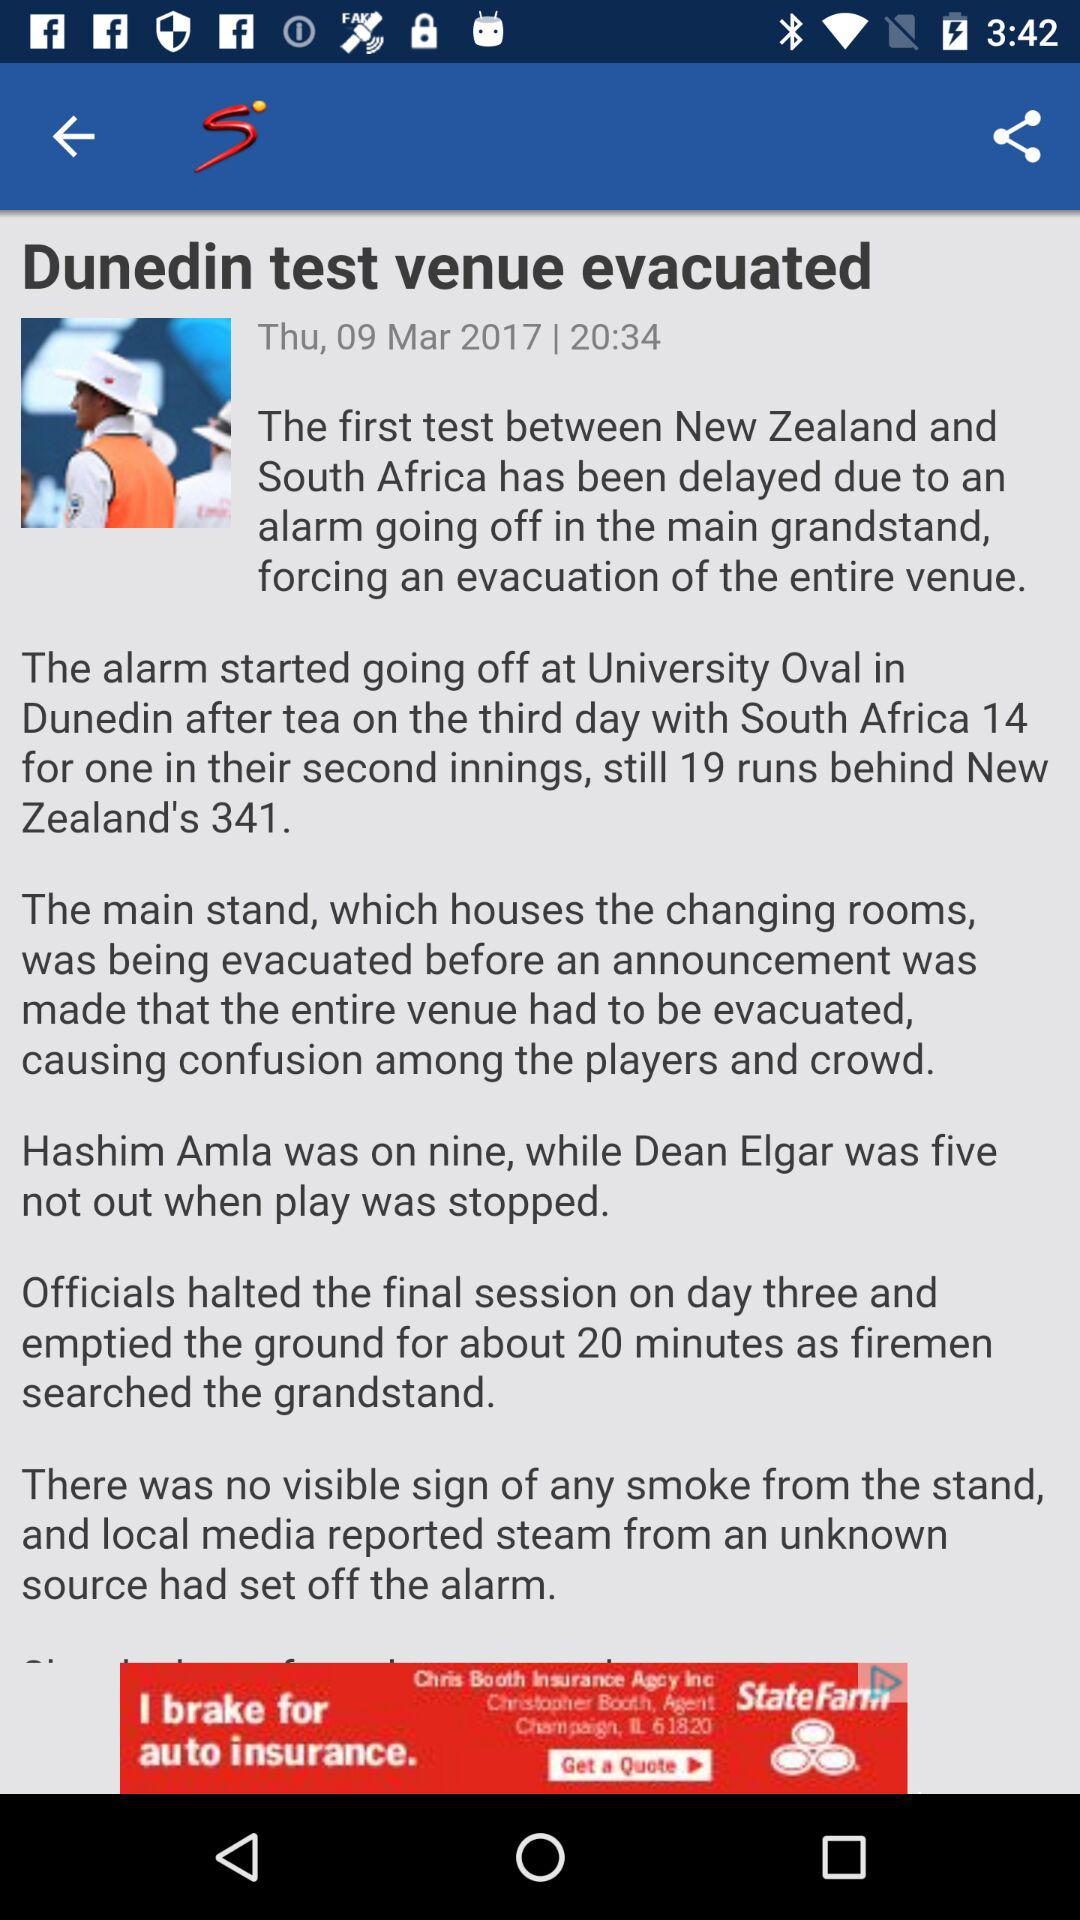How many runs were South Africa behind New Zealand?
Answer the question using a single word or phrase. 19 